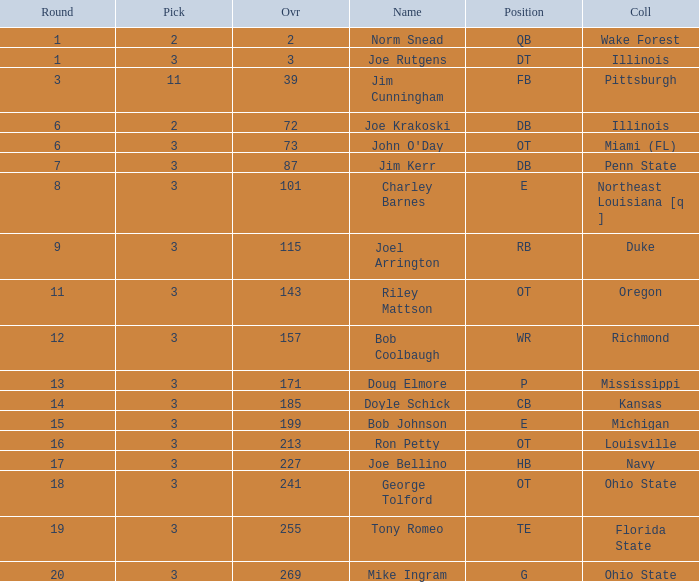How many rounds have john o'day as the name, and a pick less than 3? None. 